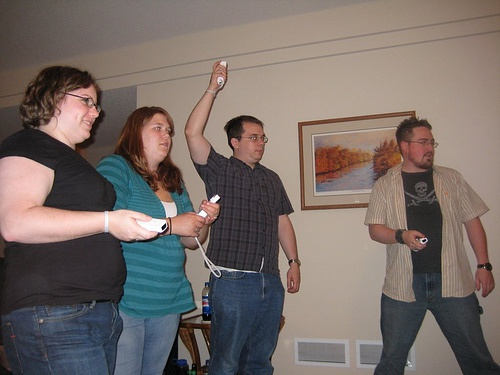Describe the objects in this image and their specific colors. I can see people in black, lightpink, and gray tones, people in black and gray tones, people in black, navy, gray, and darkblue tones, people in black, teal, and gray tones, and bottle in black, gray, navy, and darkgray tones in this image. 